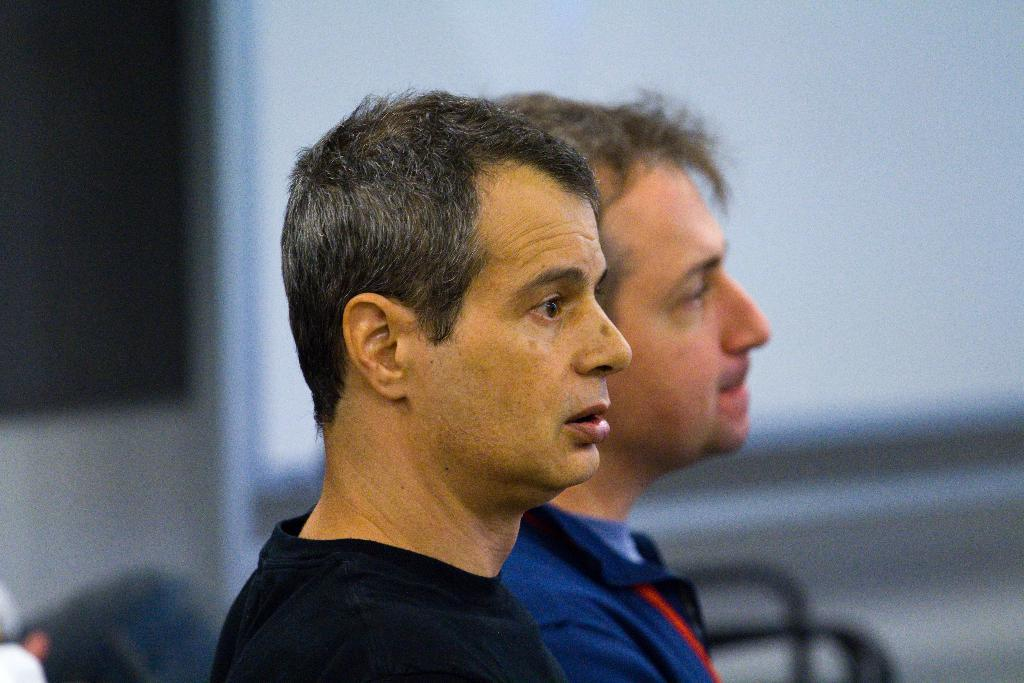How many people are in the image? There are two persons in the image. What is one of the persons wearing? One of the persons is wearing a black color t-shirt. Can you describe the background of the image? The background of the image is blurred. What type of society is depicted in the image? There is no depiction of a society in the image; it features two persons and a blurred background. Can you tell me how many baths are visible in the image? There are no baths present in the image. 